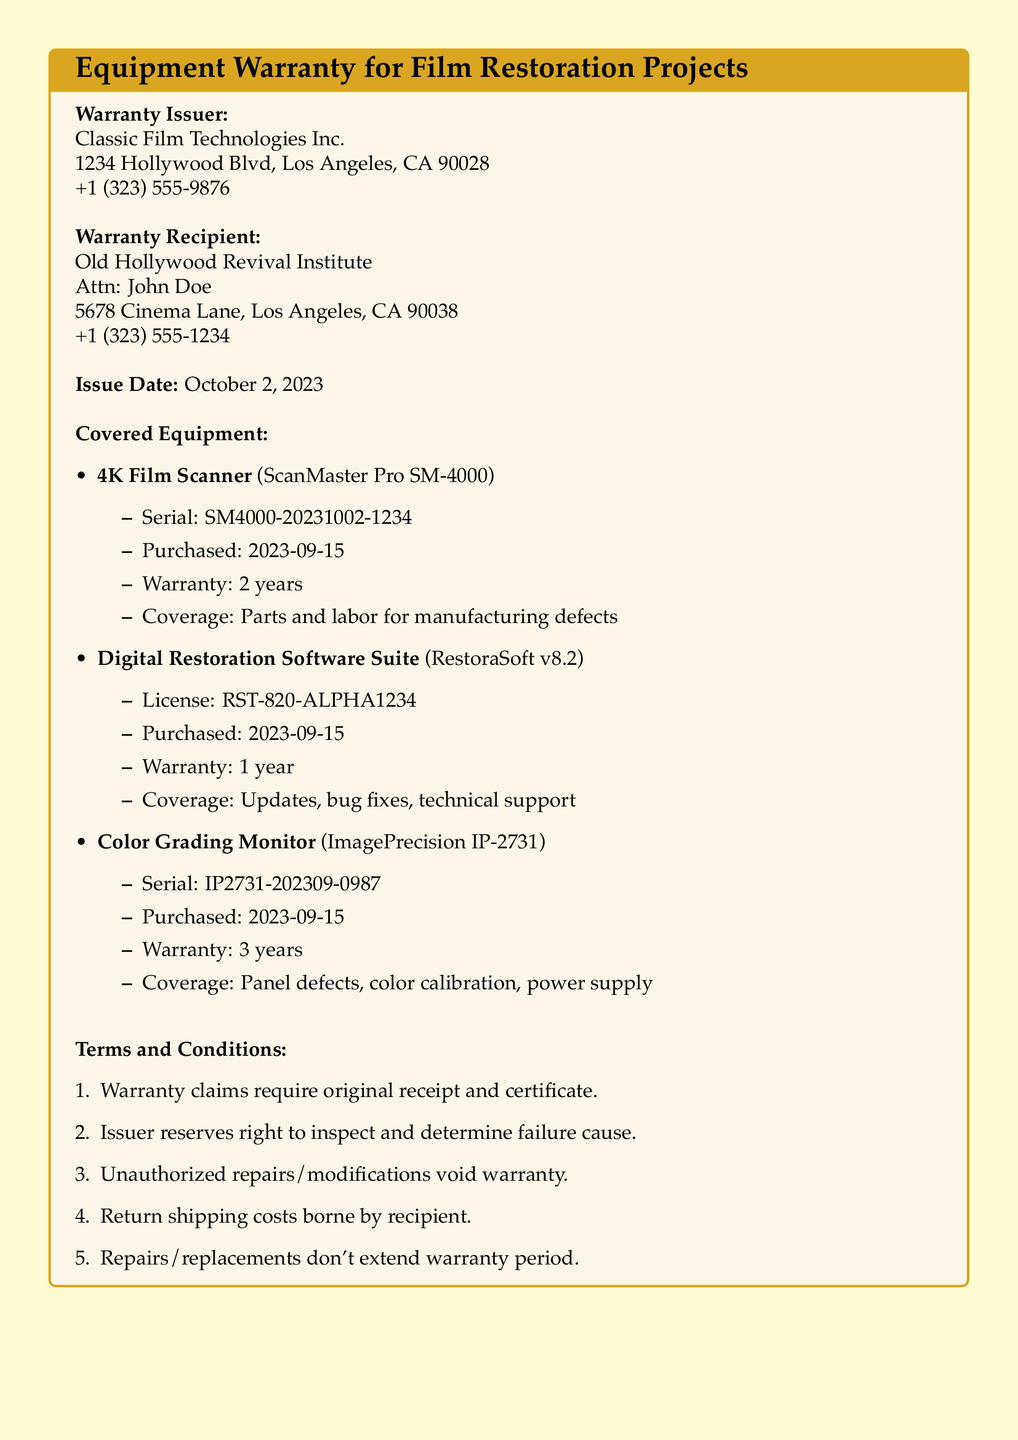What is the name of the warranty issuer? The warranty issuer is the entity that provides the warranty, found in the document under "Warranty Issuer."
Answer: Classic Film Technologies Inc What is the issue date of the warranty? The issue date refers to when the warranty was issued, noted in the document.
Answer: October 2, 2023 What is the warranty coverage period for the 4K Film Scanner? The warranty coverage period is specified in the document for each piece of equipment.
Answer: 2 years Which software is covered under the warranty? The document lists the specific equipment, including software, that is under warranty.
Answer: Digital Restoration Software Suite What should warranty claims include? The document states the requirements for making warranty claims under "Terms and Conditions."
Answer: Original receipt and certificate How long is the warranty for the Color Grading Monitor? This information is provided in the list of covered equipment in the warranty document.
Answer: 3 years Who is the warranty recipient? The warranty recipient is the individual or organization that receives the warranty, found in the document under "Warranty Recipient."
Answer: Old Hollywood Revival Institute What happens if there are unauthorized repairs? The document outlines specific conditions that void the warranty, particularly regarding repairs.
Answer: Void warranty What are the shipping costs for warranty repairs? The document states who bears the shipping costs in the "Terms and Conditions" section.
Answer: Recipient 